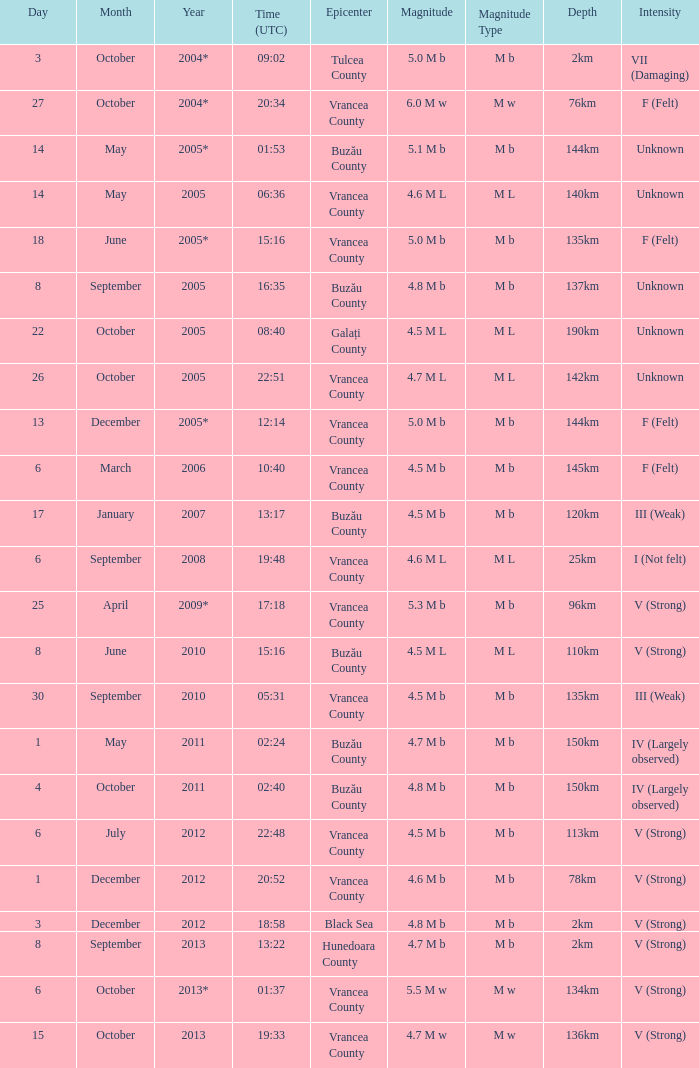What is the depth of the quake that occurred at 19:48? 25km. 